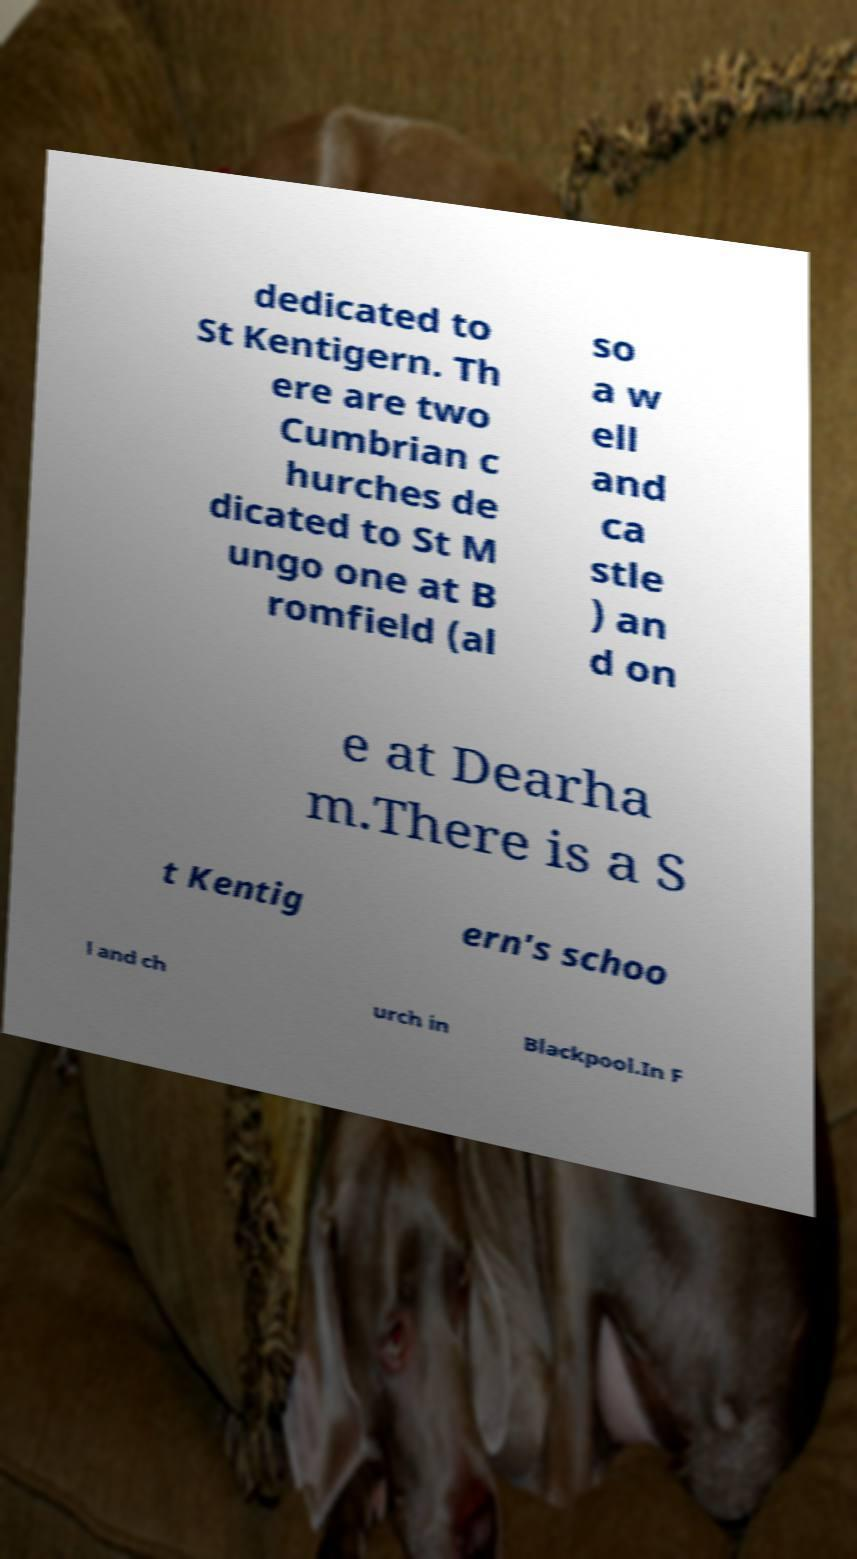For documentation purposes, I need the text within this image transcribed. Could you provide that? dedicated to St Kentigern. Th ere are two Cumbrian c hurches de dicated to St M ungo one at B romfield (al so a w ell and ca stle ) an d on e at Dearha m.There is a S t Kentig ern's schoo l and ch urch in Blackpool.In F 